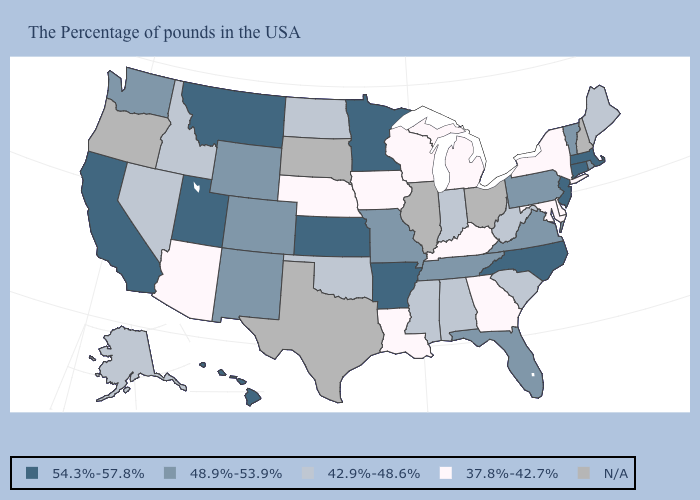What is the lowest value in the Northeast?
Concise answer only. 37.8%-42.7%. Name the states that have a value in the range N/A?
Answer briefly. New Hampshire, Ohio, Illinois, Texas, South Dakota, Oregon. What is the value of Mississippi?
Answer briefly. 42.9%-48.6%. Among the states that border New Jersey , does Delaware have the lowest value?
Keep it brief. Yes. Which states hav the highest value in the MidWest?
Give a very brief answer. Minnesota, Kansas. Among the states that border Minnesota , which have the highest value?
Concise answer only. North Dakota. Name the states that have a value in the range 54.3%-57.8%?
Give a very brief answer. Massachusetts, Connecticut, New Jersey, North Carolina, Arkansas, Minnesota, Kansas, Utah, Montana, California, Hawaii. Among the states that border Rhode Island , which have the lowest value?
Concise answer only. Massachusetts, Connecticut. Which states have the highest value in the USA?
Quick response, please. Massachusetts, Connecticut, New Jersey, North Carolina, Arkansas, Minnesota, Kansas, Utah, Montana, California, Hawaii. Is the legend a continuous bar?
Give a very brief answer. No. What is the value of New York?
Keep it brief. 37.8%-42.7%. Among the states that border Kentucky , does Indiana have the highest value?
Quick response, please. No. Does the map have missing data?
Be succinct. Yes. 